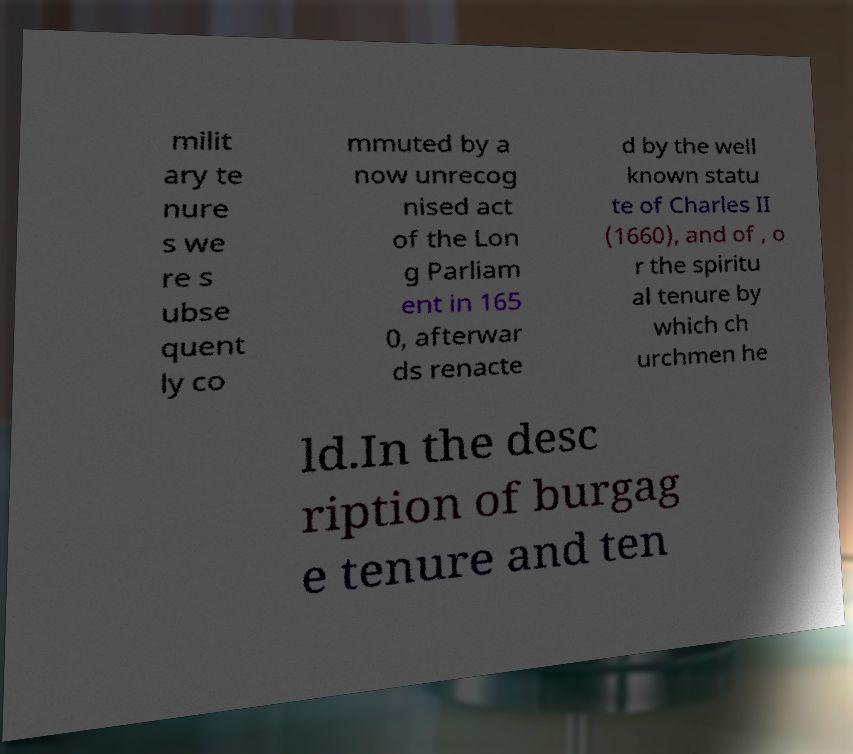Could you extract and type out the text from this image? milit ary te nure s we re s ubse quent ly co mmuted by a now unrecog nised act of the Lon g Parliam ent in 165 0, afterwar ds renacte d by the well known statu te of Charles II (1660), and of , o r the spiritu al tenure by which ch urchmen he ld.In the desc ription of burgag e tenure and ten 